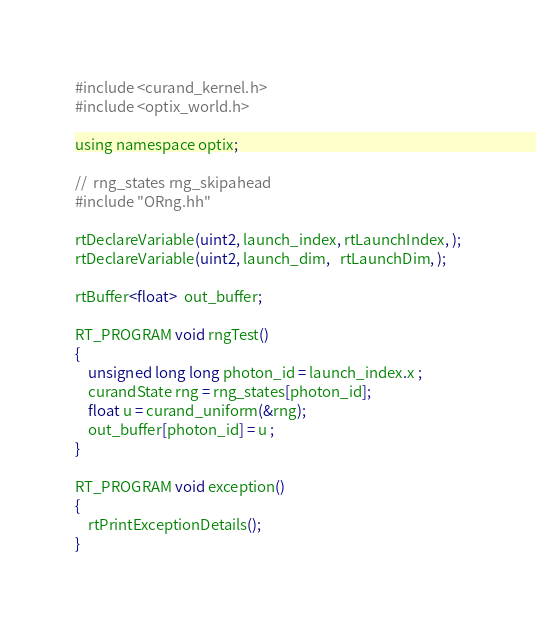Convert code to text. <code><loc_0><loc_0><loc_500><loc_500><_Cuda_>#include <curand_kernel.h>
#include <optix_world.h>

using namespace optix;

//  rng_states rng_skipahead
#include "ORng.hh"

rtDeclareVariable(uint2, launch_index, rtLaunchIndex, );
rtDeclareVariable(uint2, launch_dim,   rtLaunchDim, );

rtBuffer<float>  out_buffer;

RT_PROGRAM void rngTest()
{
    unsigned long long photon_id = launch_index.x ;
    curandState rng = rng_states[photon_id];
    float u = curand_uniform(&rng);  
    out_buffer[photon_id] = u ; 
}

RT_PROGRAM void exception()
{
    rtPrintExceptionDetails();
}

</code> 